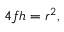Convert formula to latex. <formula><loc_0><loc_0><loc_500><loc_500>4 f h = r ^ { 2 } ,</formula> 